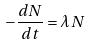Convert formula to latex. <formula><loc_0><loc_0><loc_500><loc_500>- \frac { d N } { d t } = \lambda N</formula> 